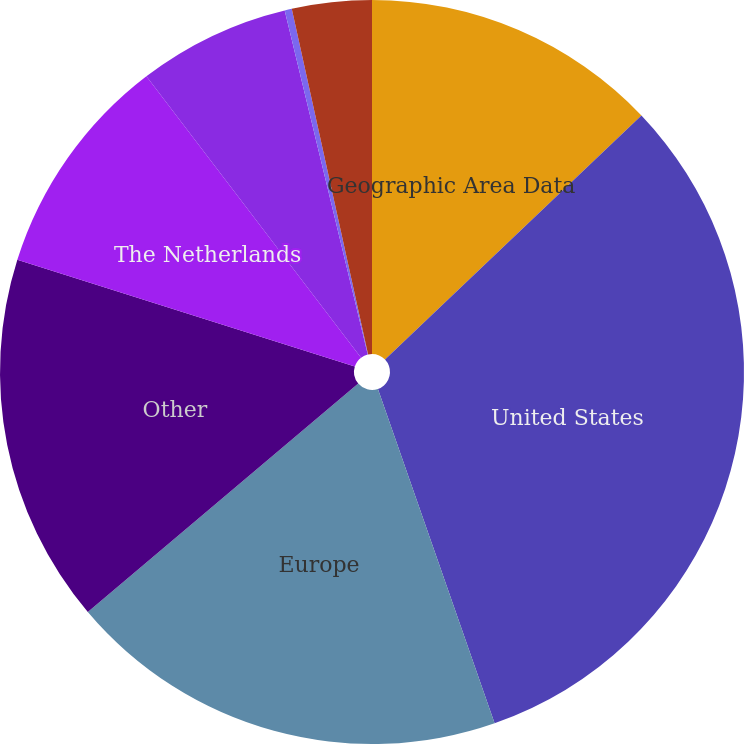Convert chart to OTSL. <chart><loc_0><loc_0><loc_500><loc_500><pie_chart><fcel>Geographic Area Data<fcel>United States<fcel>Europe<fcel>Other<fcel>The Netherlands<fcel>Germany<fcel>United Kingdom<fcel>Mexico<nl><fcel>12.89%<fcel>31.76%<fcel>19.18%<fcel>16.04%<fcel>9.75%<fcel>6.6%<fcel>0.31%<fcel>3.46%<nl></chart> 